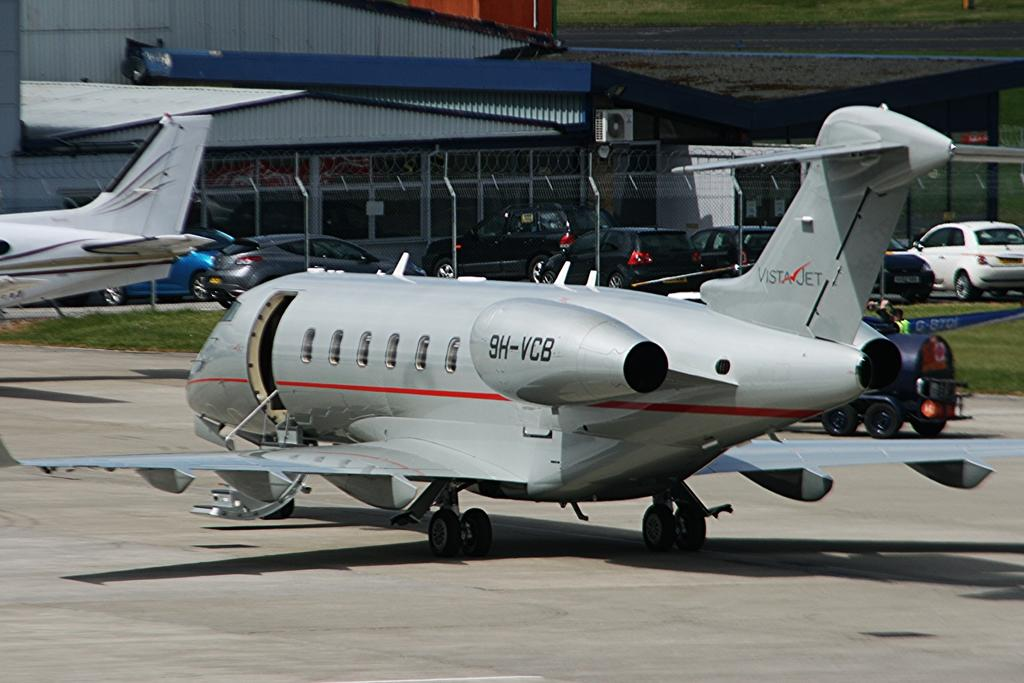<image>
Create a compact narrative representing the image presented. A plane that says VistaJet on the tail. 